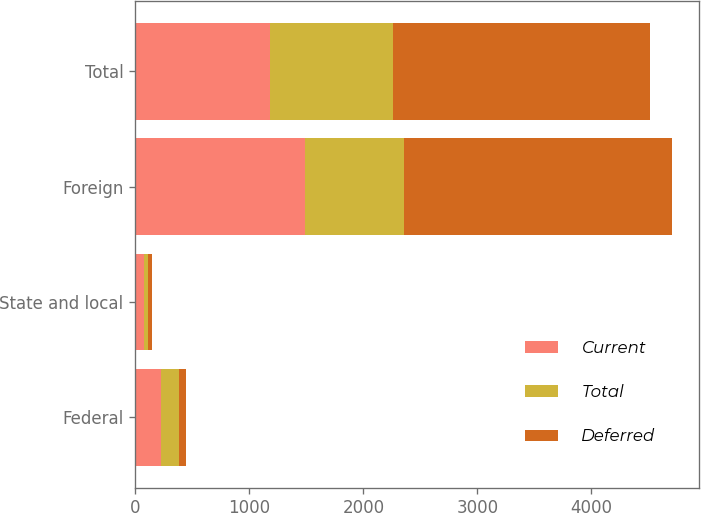Convert chart. <chart><loc_0><loc_0><loc_500><loc_500><stacked_bar_chart><ecel><fcel>Federal<fcel>State and local<fcel>Foreign<fcel>Total<nl><fcel>Current<fcel>224<fcel>75<fcel>1484<fcel>1185<nl><fcel>Total<fcel>162<fcel>40<fcel>870<fcel>1072<nl><fcel>Deferred<fcel>62<fcel>35<fcel>2354<fcel>2257<nl></chart> 